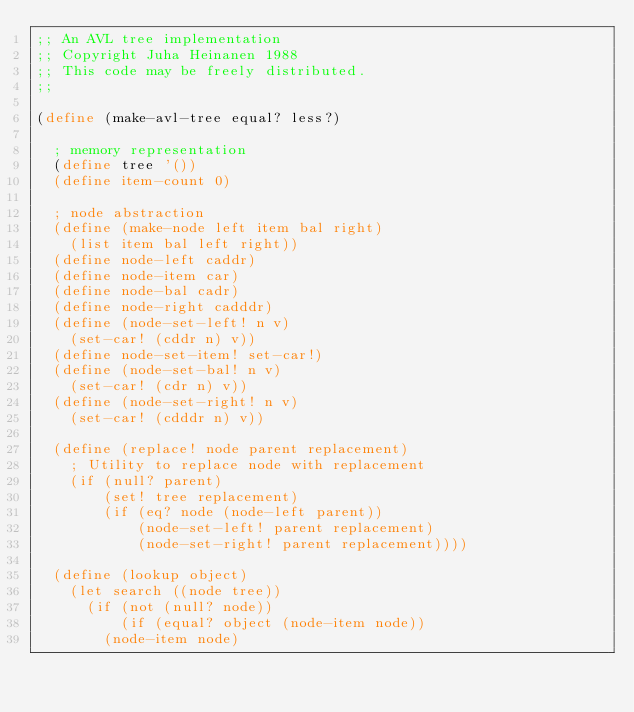Convert code to text. <code><loc_0><loc_0><loc_500><loc_500><_Scheme_>;; An AVL tree implementation
;; Copyright Juha Heinanen 1988
;; This code may be freely distributed.
;;

(define (make-avl-tree equal? less?)
  
  ; memory representation
  (define tree '())
  (define item-count 0)
  
  ; node abstraction
  (define (make-node left item bal right)
    (list item bal left right))
  (define node-left caddr)
  (define node-item car)
  (define node-bal cadr)
  (define node-right cadddr)
  (define (node-set-left! n v)
    (set-car! (cddr n) v))
  (define node-set-item! set-car!)
  (define (node-set-bal! n v)
    (set-car! (cdr n) v))
  (define (node-set-right! n v)
    (set-car! (cdddr n) v))
  
  (define (replace! node parent replacement)
    ; Utility to replace node with replacement
    (if (null? parent)
        (set! tree replacement)
        (if (eq? node (node-left parent))
            (node-set-left! parent replacement)
            (node-set-right! parent replacement))))

  (define (lookup object)
    (let search ((node tree))
      (if (not (null? node))
          (if (equal? object (node-item node))
      	(node-item node)</code> 